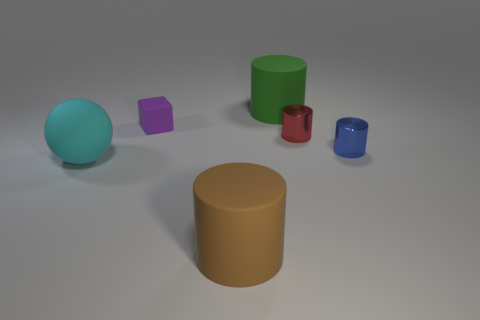Subtract all brown rubber cylinders. How many cylinders are left? 3 Subtract 3 cylinders. How many cylinders are left? 1 Add 3 tiny metallic cylinders. How many objects exist? 9 Subtract all cubes. How many objects are left? 5 Add 6 big rubber spheres. How many big rubber spheres are left? 7 Add 3 blue shiny things. How many blue shiny things exist? 4 Subtract all brown cylinders. How many cylinders are left? 3 Subtract 0 purple cylinders. How many objects are left? 6 Subtract all cyan blocks. Subtract all green balls. How many blocks are left? 1 Subtract all blue cubes. How many brown cylinders are left? 1 